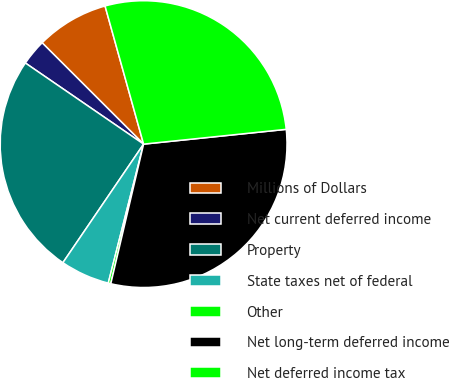Convert chart to OTSL. <chart><loc_0><loc_0><loc_500><loc_500><pie_chart><fcel>Millions of Dollars<fcel>Net current deferred income<fcel>Property<fcel>State taxes net of federal<fcel>Other<fcel>Net long-term deferred income<fcel>Net deferred income tax<nl><fcel>8.18%<fcel>2.92%<fcel>25.06%<fcel>5.55%<fcel>0.29%<fcel>30.32%<fcel>27.69%<nl></chart> 